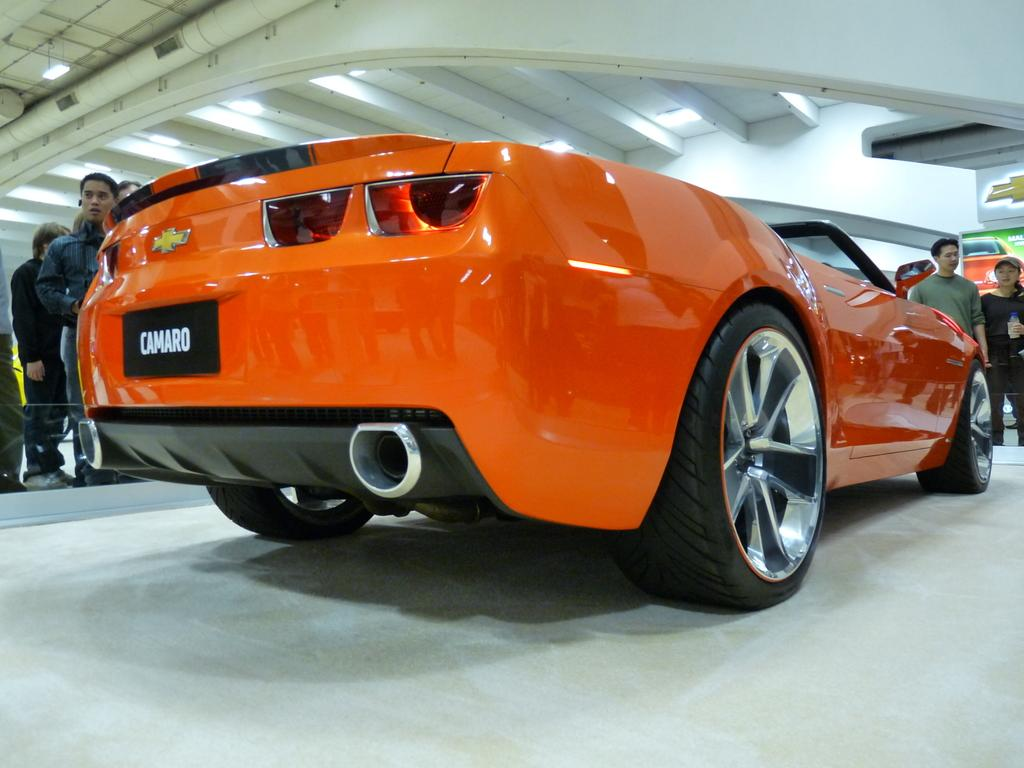What is placed on the floor in the image? There is a car on the floor in the image. What can be seen around the car? There are people around the car. What is visible above the car? The ceiling is visible in the image. What features can be observed on the ceiling? There are lights and pipes on the ceiling. How does the mist affect the condition of the car in the image? There is no mist present in the image, so it cannot affect the condition of the car. 